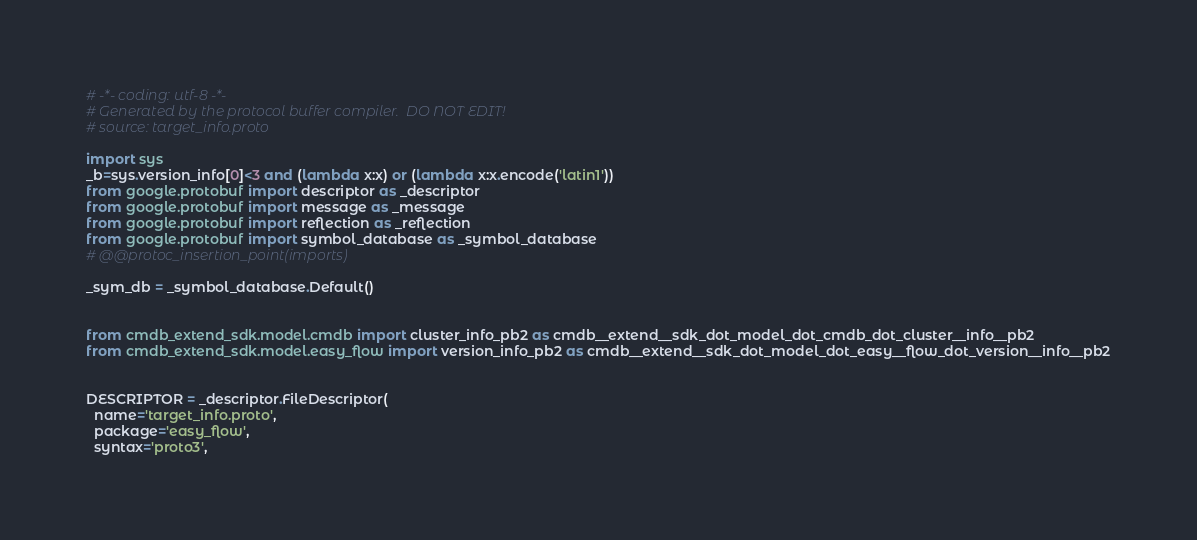Convert code to text. <code><loc_0><loc_0><loc_500><loc_500><_Python_># -*- coding: utf-8 -*-
# Generated by the protocol buffer compiler.  DO NOT EDIT!
# source: target_info.proto

import sys
_b=sys.version_info[0]<3 and (lambda x:x) or (lambda x:x.encode('latin1'))
from google.protobuf import descriptor as _descriptor
from google.protobuf import message as _message
from google.protobuf import reflection as _reflection
from google.protobuf import symbol_database as _symbol_database
# @@protoc_insertion_point(imports)

_sym_db = _symbol_database.Default()


from cmdb_extend_sdk.model.cmdb import cluster_info_pb2 as cmdb__extend__sdk_dot_model_dot_cmdb_dot_cluster__info__pb2
from cmdb_extend_sdk.model.easy_flow import version_info_pb2 as cmdb__extend__sdk_dot_model_dot_easy__flow_dot_version__info__pb2


DESCRIPTOR = _descriptor.FileDescriptor(
  name='target_info.proto',
  package='easy_flow',
  syntax='proto3',</code> 